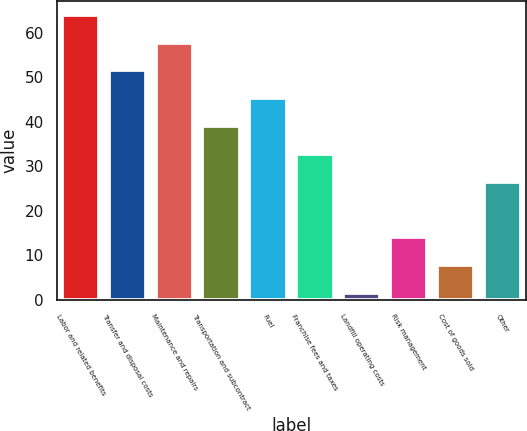<chart> <loc_0><loc_0><loc_500><loc_500><bar_chart><fcel>Labor and related benefits<fcel>Transfer and disposal costs<fcel>Maintenance and repairs<fcel>Transportation and subcontract<fcel>Fuel<fcel>Franchise fees and taxes<fcel>Landfill operating costs<fcel>Risk management<fcel>Cost of goods sold<fcel>Other<nl><fcel>64<fcel>51.52<fcel>57.76<fcel>39.04<fcel>45.28<fcel>32.8<fcel>1.6<fcel>14.08<fcel>7.84<fcel>26.56<nl></chart> 